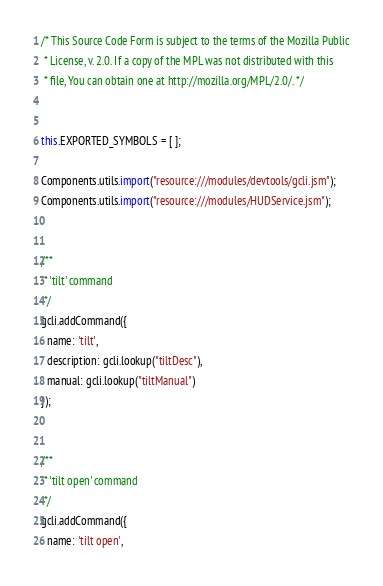<code> <loc_0><loc_0><loc_500><loc_500><_JavaScript_>/* This Source Code Form is subject to the terms of the Mozilla Public
 * License, v. 2.0. If a copy of the MPL was not distributed with this
 * file, You can obtain one at http://mozilla.org/MPL/2.0/. */


this.EXPORTED_SYMBOLS = [ ];

Components.utils.import("resource:///modules/devtools/gcli.jsm");
Components.utils.import("resource:///modules/HUDService.jsm");


/**
 * 'tilt' command
 */
gcli.addCommand({
  name: 'tilt',
  description: gcli.lookup("tiltDesc"),
  manual: gcli.lookup("tiltManual")
});


/**
 * 'tilt open' command
 */
gcli.addCommand({
  name: 'tilt open',</code> 